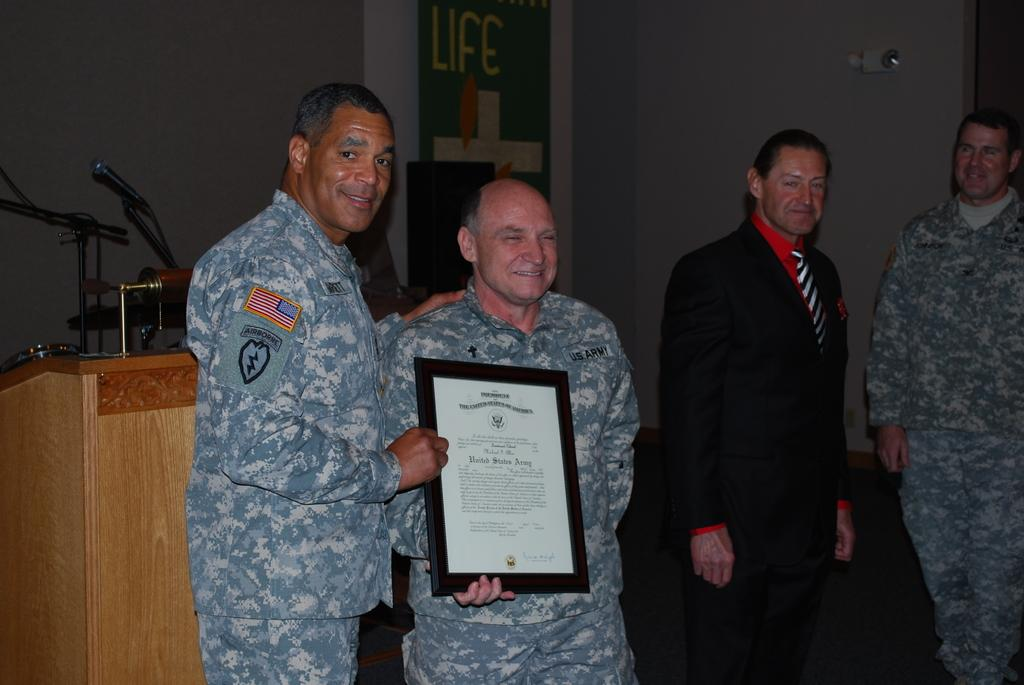How many people are present in the image? There are four people in the image. What are two of the people doing in the image? Two of the people are holding an object. What can be seen in the background of the image? There is a podium, a microphone, a wall, and some unspecified objects in the background of the image. What route are the people taking in the image? There is no indication of a route or any movement in the image; it is a still image of four people and a background. 